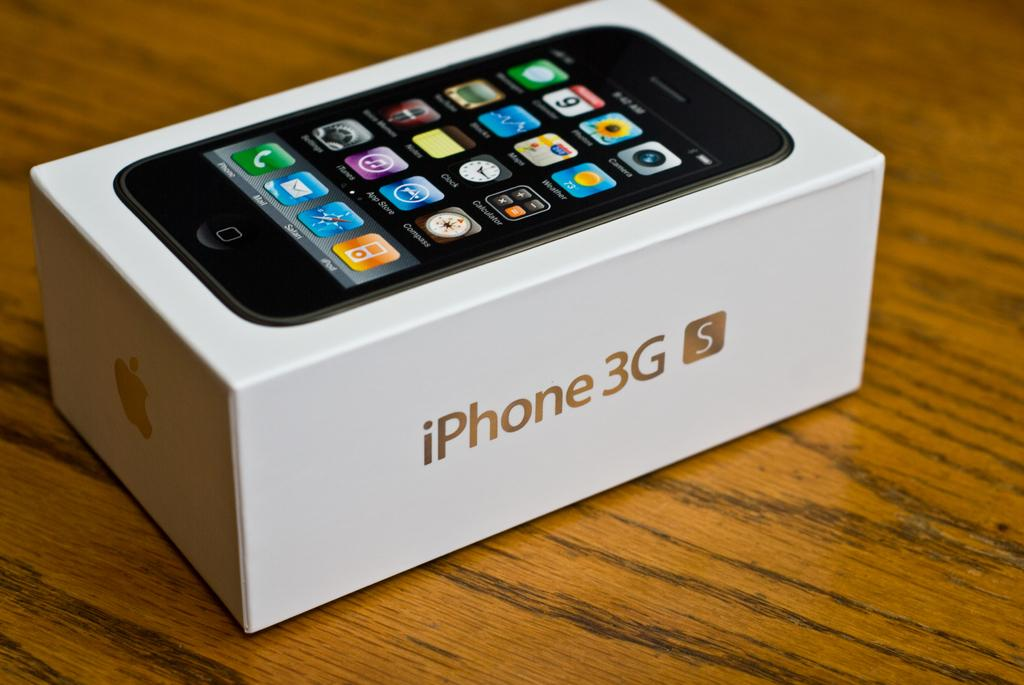<image>
Give a short and clear explanation of the subsequent image. A box that came with an iPhone 3G in it sitting on a table. 